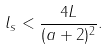Convert formula to latex. <formula><loc_0><loc_0><loc_500><loc_500>l _ { s } < \frac { 4 L } { ( a + 2 ) ^ { 2 } } .</formula> 